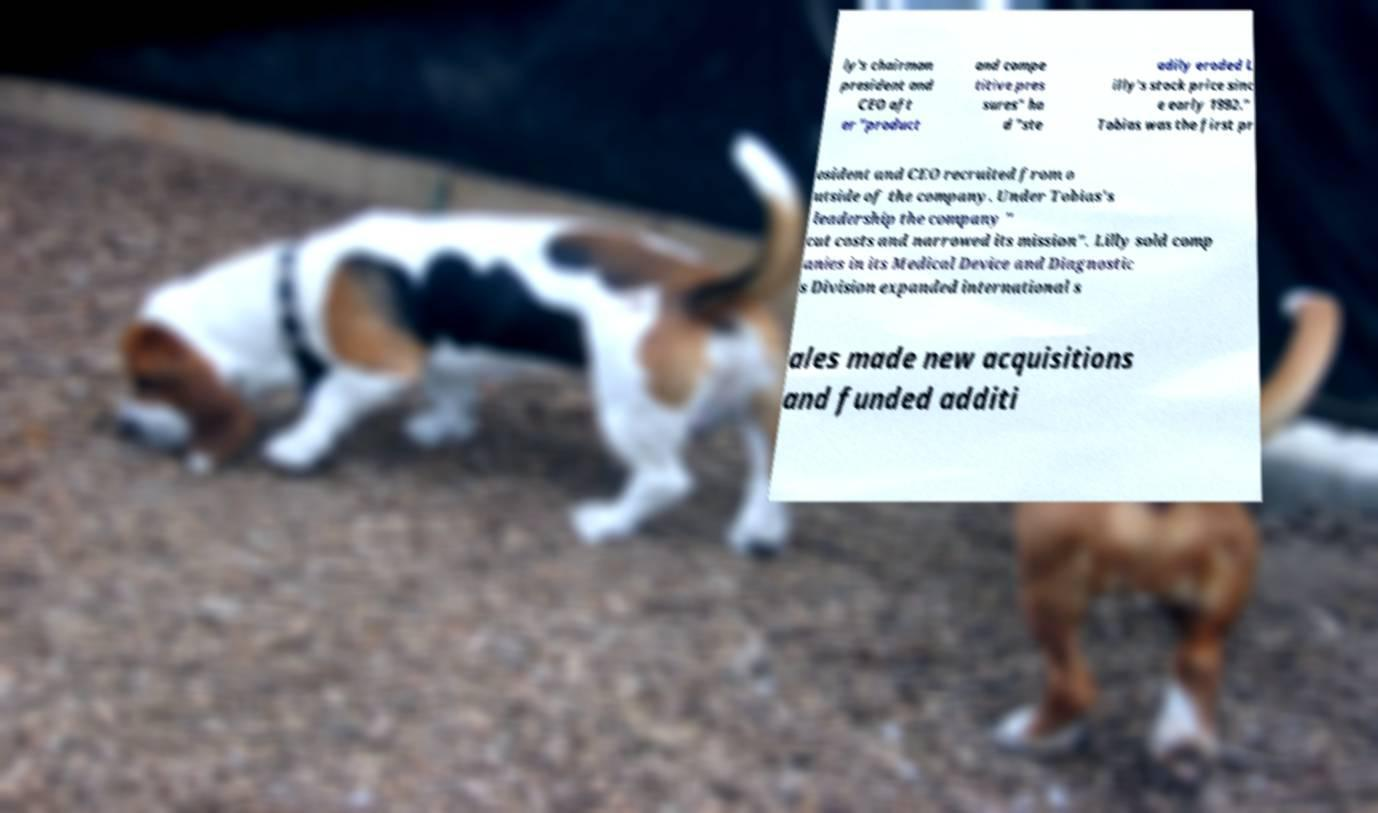Can you read and provide the text displayed in the image?This photo seems to have some interesting text. Can you extract and type it out for me? ly's chairman president and CEO aft er "product and compe titive pres sures" ha d "ste adily eroded L illy's stock price sinc e early 1992." Tobias was the first pr esident and CEO recruited from o utside of the company. Under Tobias's leadership the company " cut costs and narrowed its mission". Lilly sold comp anies in its Medical Device and Diagnostic s Division expanded international s ales made new acquisitions and funded additi 